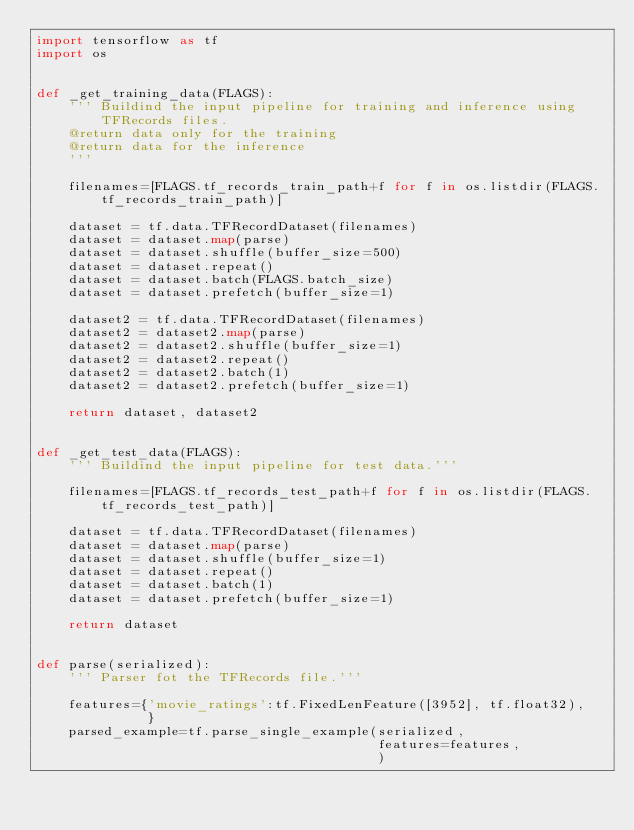<code> <loc_0><loc_0><loc_500><loc_500><_Python_>import tensorflow as tf
import os


def _get_training_data(FLAGS):  
    ''' Buildind the input pipeline for training and inference using TFRecords files.
    @return data only for the training
    @return data for the inference
    '''
    
    filenames=[FLAGS.tf_records_train_path+f for f in os.listdir(FLAGS.tf_records_train_path)]
    
    dataset = tf.data.TFRecordDataset(filenames)
    dataset = dataset.map(parse)
    dataset = dataset.shuffle(buffer_size=500)
    dataset = dataset.repeat()
    dataset = dataset.batch(FLAGS.batch_size)
    dataset = dataset.prefetch(buffer_size=1)
    
    dataset2 = tf.data.TFRecordDataset(filenames)
    dataset2 = dataset2.map(parse)
    dataset2 = dataset2.shuffle(buffer_size=1)
    dataset2 = dataset2.repeat()
    dataset2 = dataset2.batch(1)
    dataset2 = dataset2.prefetch(buffer_size=1)
    
    return dataset, dataset2
    

def _get_test_data(FLAGS):
    ''' Buildind the input pipeline for test data.'''
    
    filenames=[FLAGS.tf_records_test_path+f for f in os.listdir(FLAGS.tf_records_test_path)]
    
    dataset = tf.data.TFRecordDataset(filenames)
    dataset = dataset.map(parse)
    dataset = dataset.shuffle(buffer_size=1)
    dataset = dataset.repeat()
    dataset = dataset.batch(1)
    dataset = dataset.prefetch(buffer_size=1)
    
    return dataset


def parse(serialized):
    ''' Parser fot the TFRecords file.'''
    
    features={'movie_ratings':tf.FixedLenFeature([3952], tf.float32),  
              }
    parsed_example=tf.parse_single_example(serialized,
                                           features=features,
                                           )</code> 